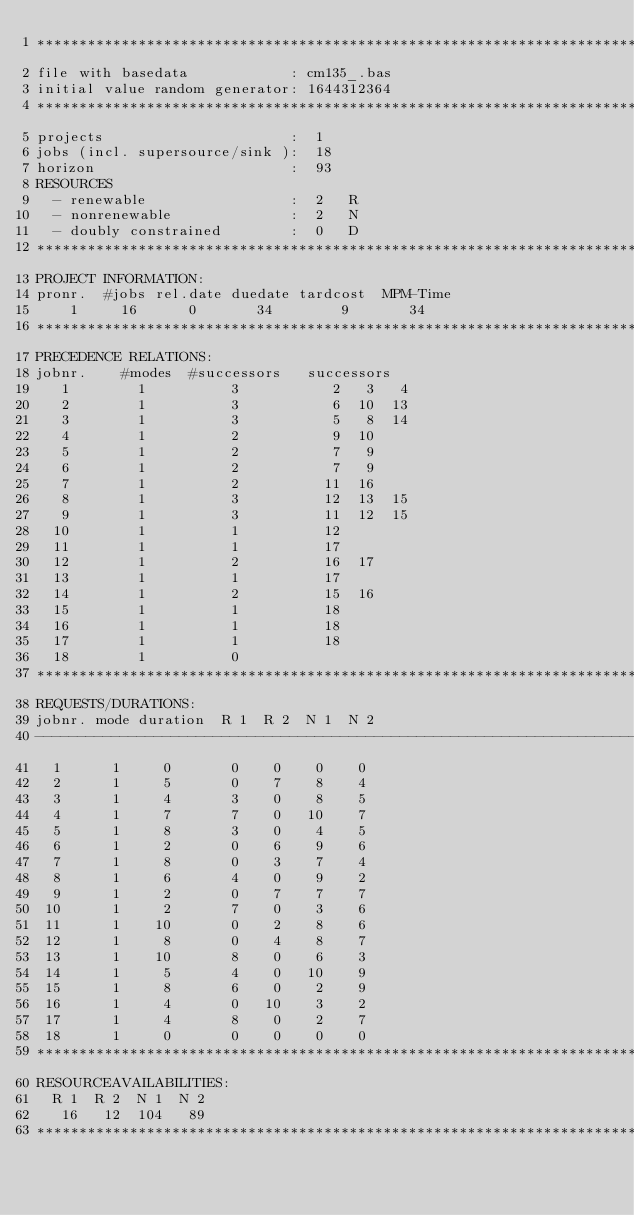Convert code to text. <code><loc_0><loc_0><loc_500><loc_500><_ObjectiveC_>************************************************************************
file with basedata            : cm135_.bas
initial value random generator: 1644312364
************************************************************************
projects                      :  1
jobs (incl. supersource/sink ):  18
horizon                       :  93
RESOURCES
  - renewable                 :  2   R
  - nonrenewable              :  2   N
  - doubly constrained        :  0   D
************************************************************************
PROJECT INFORMATION:
pronr.  #jobs rel.date duedate tardcost  MPM-Time
    1     16      0       34        9       34
************************************************************************
PRECEDENCE RELATIONS:
jobnr.    #modes  #successors   successors
   1        1          3           2   3   4
   2        1          3           6  10  13
   3        1          3           5   8  14
   4        1          2           9  10
   5        1          2           7   9
   6        1          2           7   9
   7        1          2          11  16
   8        1          3          12  13  15
   9        1          3          11  12  15
  10        1          1          12
  11        1          1          17
  12        1          2          16  17
  13        1          1          17
  14        1          2          15  16
  15        1          1          18
  16        1          1          18
  17        1          1          18
  18        1          0        
************************************************************************
REQUESTS/DURATIONS:
jobnr. mode duration  R 1  R 2  N 1  N 2
------------------------------------------------------------------------
  1      1     0       0    0    0    0
  2      1     5       0    7    8    4
  3      1     4       3    0    8    5
  4      1     7       7    0   10    7
  5      1     8       3    0    4    5
  6      1     2       0    6    9    6
  7      1     8       0    3    7    4
  8      1     6       4    0    9    2
  9      1     2       0    7    7    7
 10      1     2       7    0    3    6
 11      1    10       0    2    8    6
 12      1     8       0    4    8    7
 13      1    10       8    0    6    3
 14      1     5       4    0   10    9
 15      1     8       6    0    2    9
 16      1     4       0   10    3    2
 17      1     4       8    0    2    7
 18      1     0       0    0    0    0
************************************************************************
RESOURCEAVAILABILITIES:
  R 1  R 2  N 1  N 2
   16   12  104   89
************************************************************************
</code> 